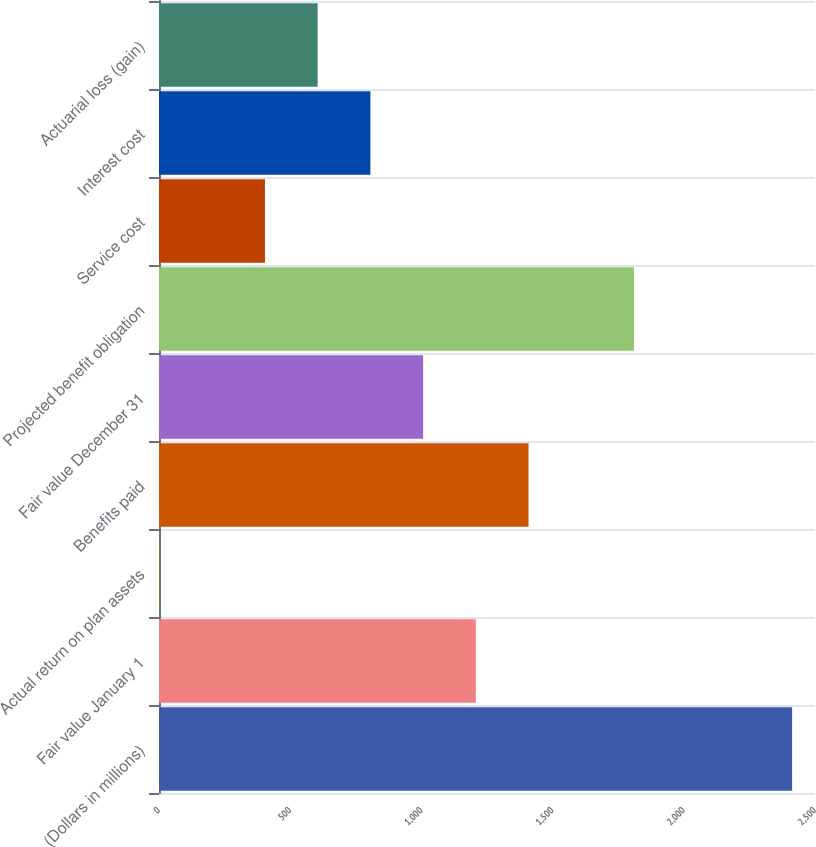<chart> <loc_0><loc_0><loc_500><loc_500><bar_chart><fcel>(Dollars in millions)<fcel>Fair value January 1<fcel>Actual return on plan assets<fcel>Benefits paid<fcel>Fair value December 31<fcel>Projected benefit obligation<fcel>Service cost<fcel>Interest cost<fcel>Actuarial loss (gain)<nl><fcel>2412.8<fcel>1207.4<fcel>2<fcel>1408.3<fcel>1006.5<fcel>1810.1<fcel>403.8<fcel>805.6<fcel>604.7<nl></chart> 